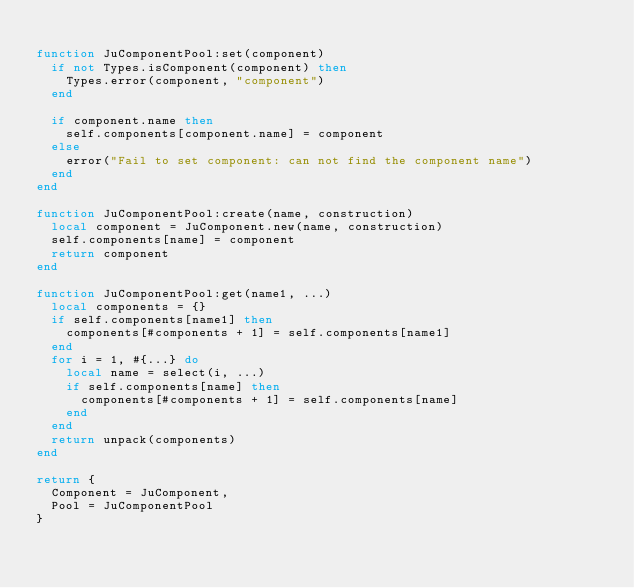<code> <loc_0><loc_0><loc_500><loc_500><_Lua_>
function JuComponentPool:set(component)
	if not Types.isComponent(component) then
		Types.error(component, "component")
	end
	
	if component.name then
		self.components[component.name] = component
	else
		error("Fail to set component: can not find the component name")
	end
end

function JuComponentPool:create(name, construction)
	local component = JuComponent.new(name, construction)
	self.components[name] = component
	return component
end

function JuComponentPool:get(name1, ...)
	local components = {}
	if self.components[name1] then
		components[#components + 1] = self.components[name1]
	end
	for i = 1, #{...} do
		local name = select(i, ...)
		if self.components[name] then
			components[#components + 1] = self.components[name]
		end
	end
	return unpack(components)
end

return {
	Component = JuComponent,
	Pool = JuComponentPool
}</code> 